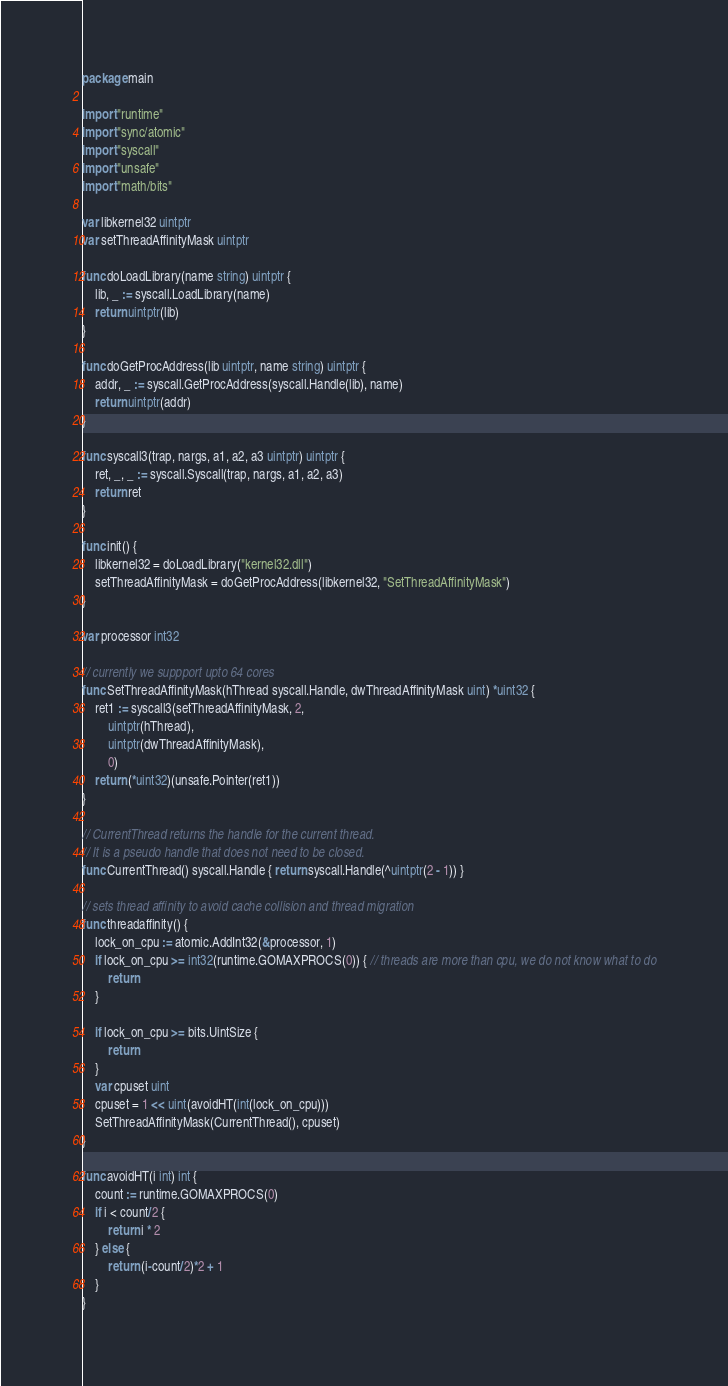Convert code to text. <code><loc_0><loc_0><loc_500><loc_500><_Go_>package main

import "runtime"
import "sync/atomic"
import "syscall"
import "unsafe"
import "math/bits"

var libkernel32 uintptr
var setThreadAffinityMask uintptr

func doLoadLibrary(name string) uintptr {
	lib, _ := syscall.LoadLibrary(name)
	return uintptr(lib)
}

func doGetProcAddress(lib uintptr, name string) uintptr {
	addr, _ := syscall.GetProcAddress(syscall.Handle(lib), name)
	return uintptr(addr)
}

func syscall3(trap, nargs, a1, a2, a3 uintptr) uintptr {
	ret, _, _ := syscall.Syscall(trap, nargs, a1, a2, a3)
	return ret
}

func init() {
	libkernel32 = doLoadLibrary("kernel32.dll")
	setThreadAffinityMask = doGetProcAddress(libkernel32, "SetThreadAffinityMask")
}

var processor int32

// currently we suppport upto 64 cores
func SetThreadAffinityMask(hThread syscall.Handle, dwThreadAffinityMask uint) *uint32 {
	ret1 := syscall3(setThreadAffinityMask, 2,
		uintptr(hThread),
		uintptr(dwThreadAffinityMask),
		0)
	return (*uint32)(unsafe.Pointer(ret1))
}

// CurrentThread returns the handle for the current thread.
// It is a pseudo handle that does not need to be closed.
func CurrentThread() syscall.Handle { return syscall.Handle(^uintptr(2 - 1)) }

// sets thread affinity to avoid cache collision and thread migration
func threadaffinity() {
	lock_on_cpu := atomic.AddInt32(&processor, 1)
	if lock_on_cpu >= int32(runtime.GOMAXPROCS(0)) { // threads are more than cpu, we do not know what to do
		return
	}

	if lock_on_cpu >= bits.UintSize {
		return
	}
	var cpuset uint
	cpuset = 1 << uint(avoidHT(int(lock_on_cpu)))
	SetThreadAffinityMask(CurrentThread(), cpuset)
}

func avoidHT(i int) int {
	count := runtime.GOMAXPROCS(0)
	if i < count/2 {
		return i * 2
	} else {
		return (i-count/2)*2 + 1
	}
}
</code> 